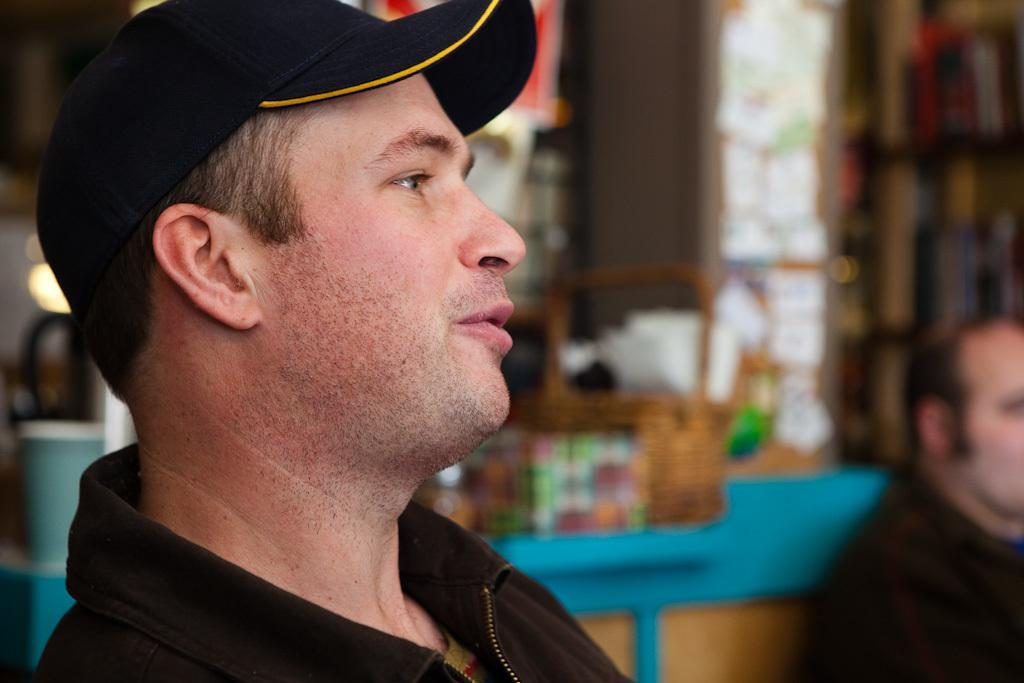How many people are in the image? There are two men in the image. What is located behind the men? There is a basket behind the men. Can you describe the background of the image? The background of the image is blurred. What type of iron is being used by the men in the image? There is no iron present in the image; it features two men and a basket. 